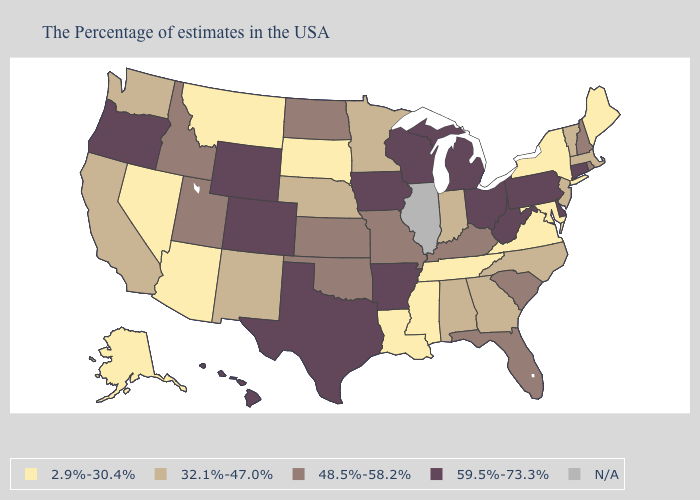What is the value of Connecticut?
Write a very short answer. 59.5%-73.3%. Does Maryland have the lowest value in the USA?
Give a very brief answer. Yes. Name the states that have a value in the range 2.9%-30.4%?
Keep it brief. Maine, New York, Maryland, Virginia, Tennessee, Mississippi, Louisiana, South Dakota, Montana, Arizona, Nevada, Alaska. Name the states that have a value in the range 48.5%-58.2%?
Answer briefly. Rhode Island, New Hampshire, South Carolina, Florida, Kentucky, Missouri, Kansas, Oklahoma, North Dakota, Utah, Idaho. Name the states that have a value in the range 48.5%-58.2%?
Answer briefly. Rhode Island, New Hampshire, South Carolina, Florida, Kentucky, Missouri, Kansas, Oklahoma, North Dakota, Utah, Idaho. Among the states that border Delaware , does Pennsylvania have the highest value?
Concise answer only. Yes. Among the states that border Arizona , which have the lowest value?
Be succinct. Nevada. Name the states that have a value in the range 2.9%-30.4%?
Give a very brief answer. Maine, New York, Maryland, Virginia, Tennessee, Mississippi, Louisiana, South Dakota, Montana, Arizona, Nevada, Alaska. What is the lowest value in the West?
Answer briefly. 2.9%-30.4%. Does the map have missing data?
Short answer required. Yes. How many symbols are there in the legend?
Give a very brief answer. 5. Among the states that border Ohio , does Kentucky have the highest value?
Write a very short answer. No. What is the value of Florida?
Short answer required. 48.5%-58.2%. 